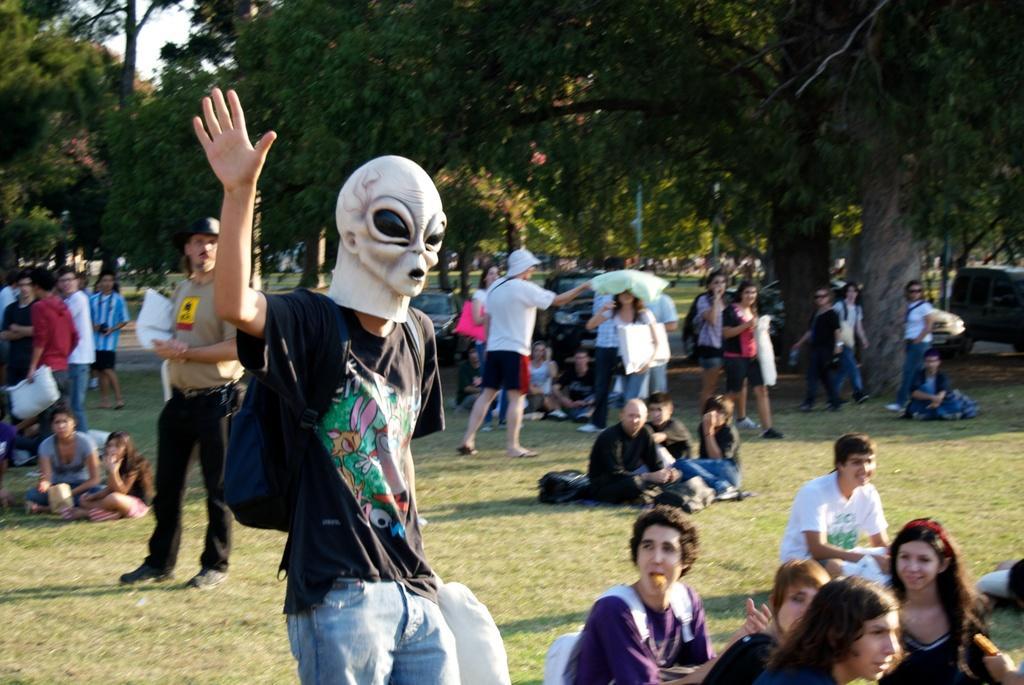Could you give a brief overview of what you see in this image? In the center of the image we can see a person is standing and he is wearing a bag and he is in a different costume. And we can see he is wearing a mask. On the right side of the image we can see a few people are sitting and they are in different costumes. Among them, we can see a few people are smiling and a few people are holding some objects. In the background, we can see the sky, trees, grass, vehicles, few people are sitting, few people are standing, few people are holding some objects and a few other objects. 